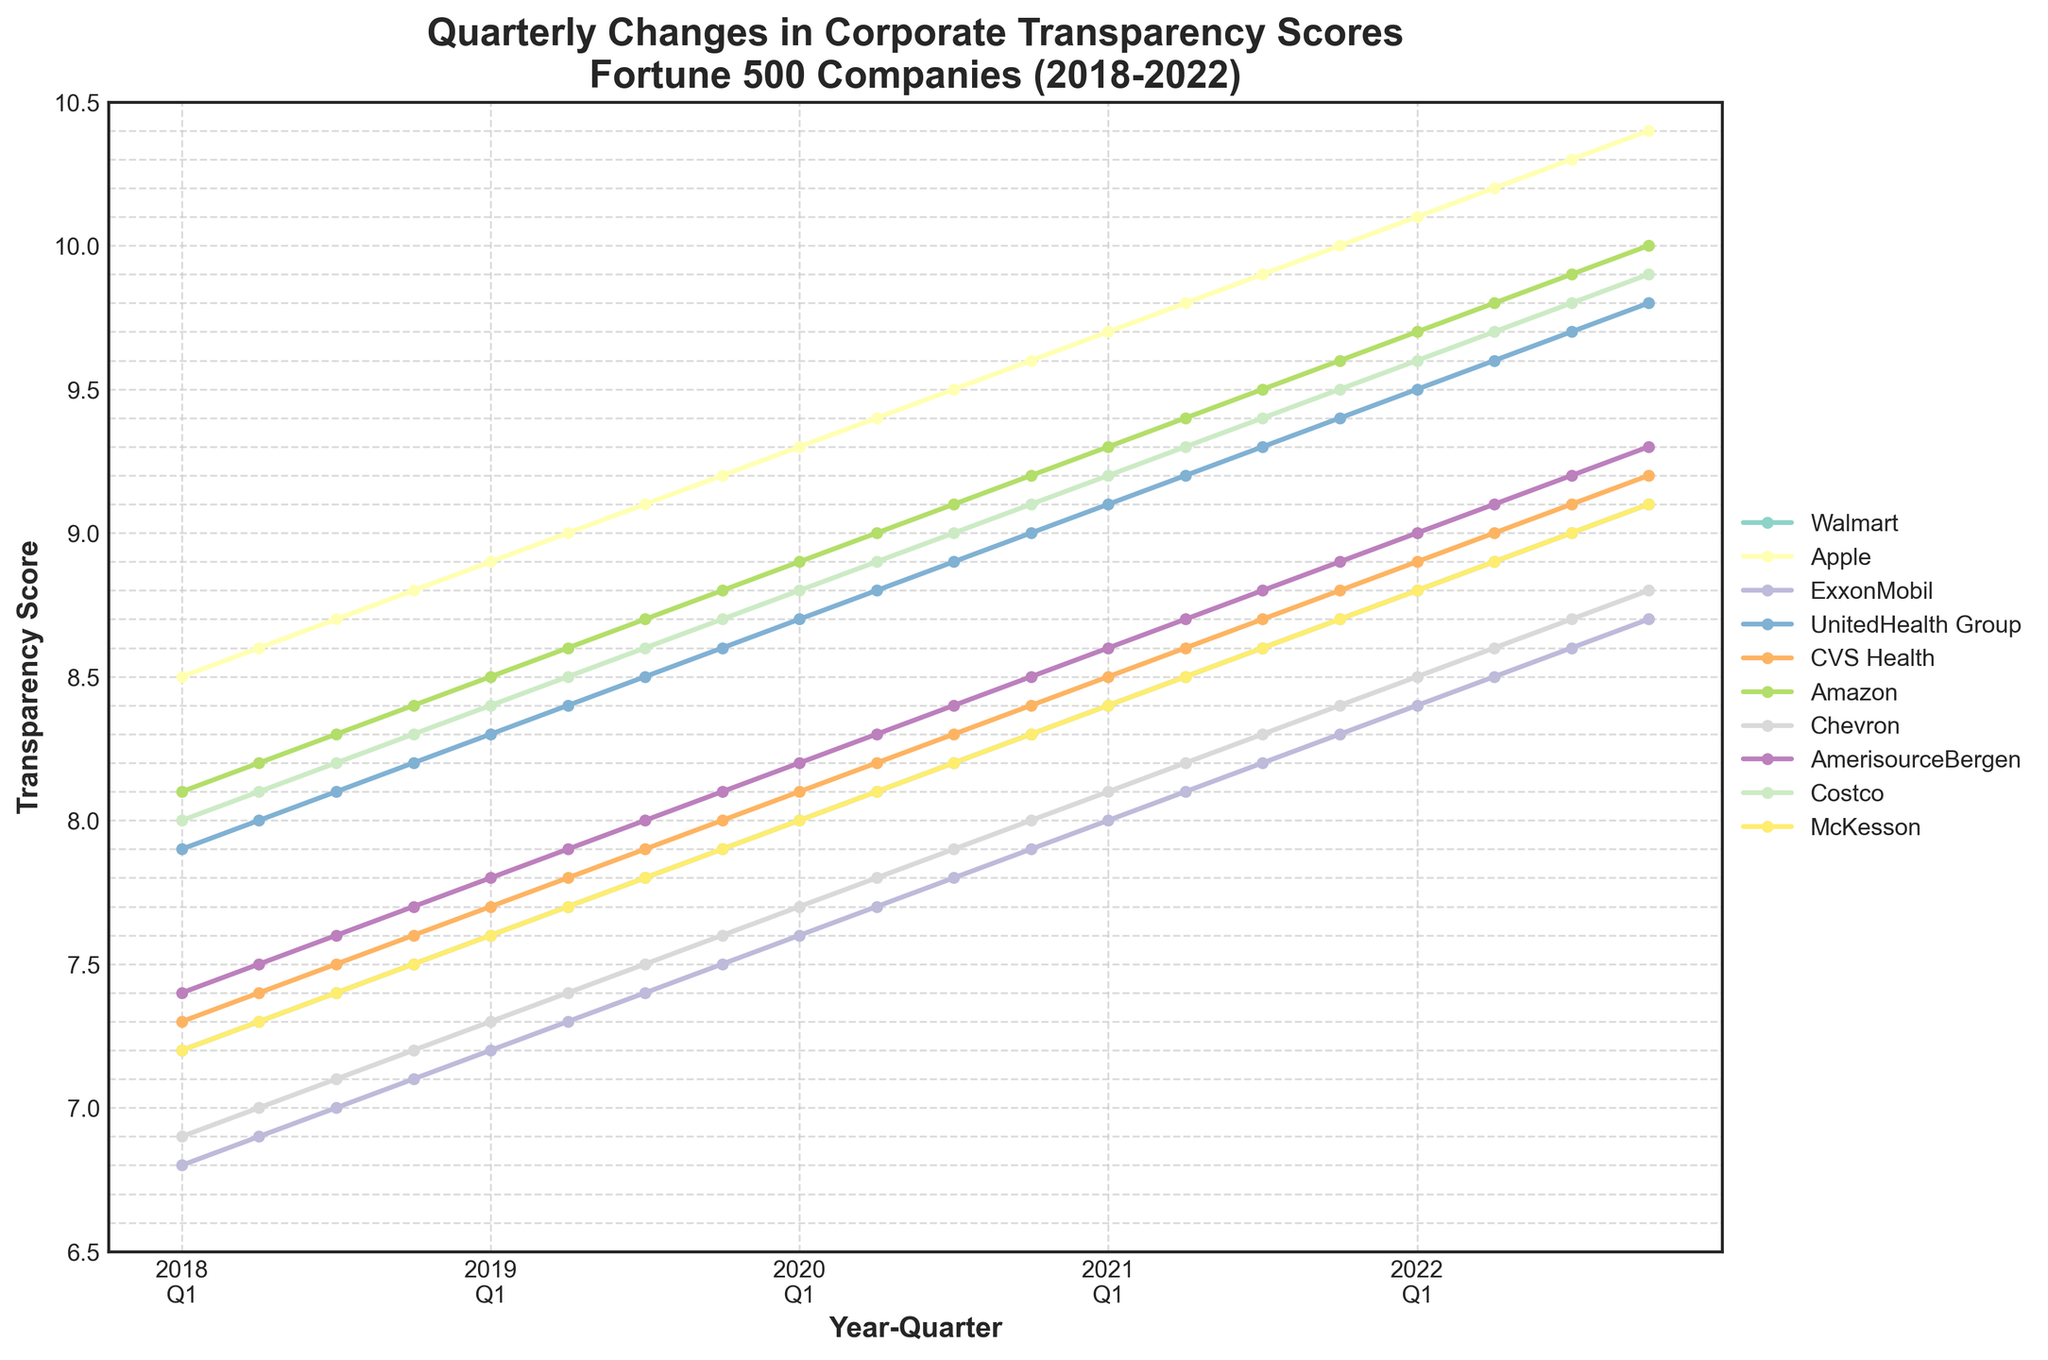1. Which company had the highest transparency score in Q4 2022? Look at the scores for Q4 2022 and identify the highest value. Apple has the highest transparency score of 10.4 in Q4 2022.
Answer: Apple 2. What was the trend in transparency scores for Walmart from 2018 to 2022? Observe the line representing Walmart. From 2018 to 2022, the transparency score for Walmart shows a consistent upward trend, starting at 7.2 in Q1 2018 and ending at 9.1 in Q4 2022.
Answer: Upward trend 3. How many companies had a transparency score greater than 9.0 in Q1 2021? Check the transparency scores for all companies in Q1 2021. Apple (9.7), UnitedHealth Group (9.1), and Amazon (9.3) all had scores greater than 9.0.
Answer: 3 companies 4. Which two companies' transparency scores intersected the most times over the five years? Look for lines that cross each other the most times on the chart. Chevron and AmerisourceBergen's lines intersect the most times over the five years.
Answer: Chevron and AmerisourceBergen 5. Compare the transparency score growth between ExxonMobil and CVS Health from 2018 to 2022. Calculate the difference for each company's score between 2018 Q1 and 2022 Q4. ExxonMobil's score grew from 6.8 to 8.7 (1.9 increase), while CVS Health's score grew from 7.3 to 9.2 (1.9 increase too). Both companies showed the same growth.
Answer: Same growth (1.9 points) 6. What is the average transparency score for Amazon over the entire period? Sum up Amazon’s scores from Q1 2018 to Q4 2022 and divide by the number of observations (20 quarters). Sum = 8.1 + 8.2 + 8.3 + ... + 10.0 = 197.1. Average = 197.1 / 20 = 9.855.
Answer: 9.855 7. During which quarter did Costco show the largest increase in transparency score within a single year? Look at the differences between scores within each year for Costco. The largest increase is from Q2 2022 to Q3 2022, where the score increased from 8.9 to 9.0 (0.1 points).
Answer: Q3 2022 8. How did the transparency score of McKesson in Q2 2018 compare to the same quarter in 2021? Find McKesson's scores for Q2 2018 (7.3) and Q2 2021 (8.5), then compare. McKesson’s score was lower in Q2 2018 compared to Q2 2021.
Answer: Lower in 2018 9. What is the minimum transparency score observed across all companies and quarters? Find the lowest value in the dataset. The lowest score observed is ExxonMobil’s 6.8 in Q1 2018.
Answer: ExxonMobil's 6.8 in Q1 2018 10. Did any company maintain a perfectly linear increase in transparency scores over the period? Check if any company's line is straight with a consistent slope. Apple’s transparency score increased linearly from 8.5 in Q1 2018 to 10.4 in Q4 2022, with a consistent increase each quarter.
Answer: Apple 